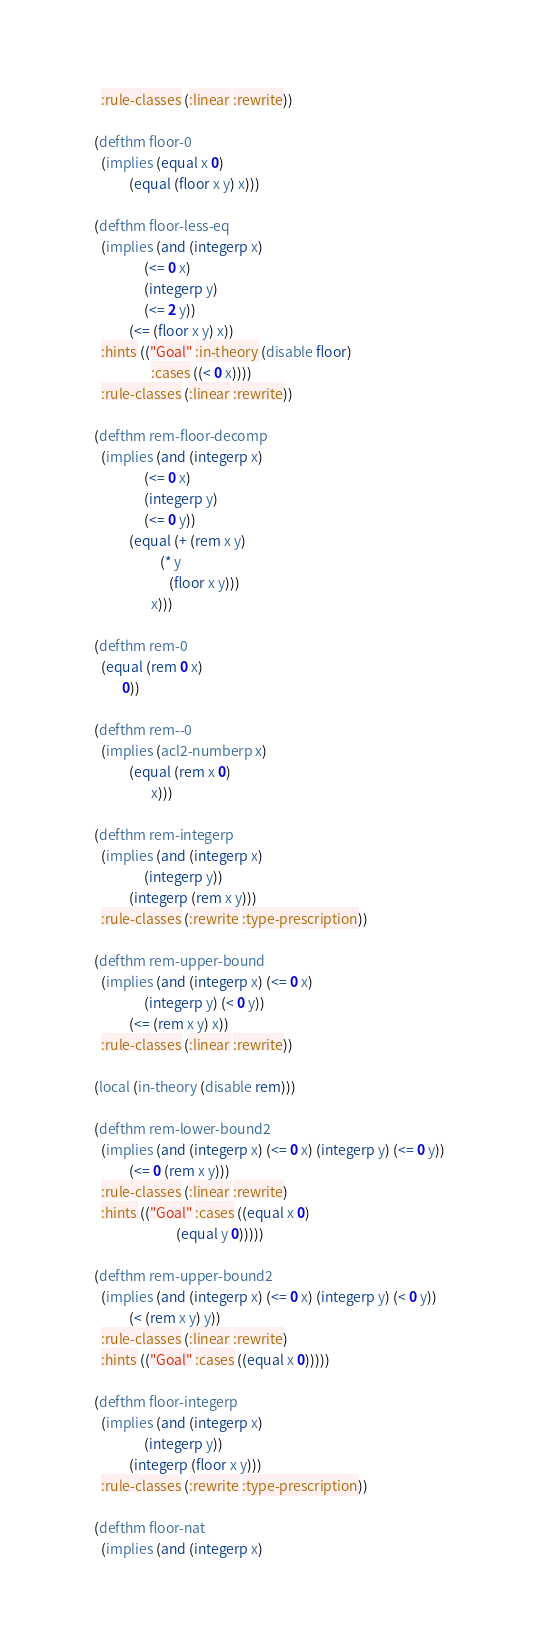<code> <loc_0><loc_0><loc_500><loc_500><_Lisp_>    :rule-classes (:linear :rewrite))
  
  (defthm floor-0
    (implies (equal x 0)
             (equal (floor x y) x)))
  
  (defthm floor-less-eq
    (implies (and (integerp x)
                  (<= 0 x)
                  (integerp y)
                  (<= 2 y))
             (<= (floor x y) x))
    :hints (("Goal" :in-theory (disable floor)
                    :cases ((< 0 x))))
    :rule-classes (:linear :rewrite))

  (defthm rem-floor-decomp
    (implies (and (integerp x)
                  (<= 0 x)
                  (integerp y)
                  (<= 0 y))
             (equal (+ (rem x y)
                       (* y
                          (floor x y)))
                    x)))
  
  (defthm rem-0
    (equal (rem 0 x)
           0))
  
  (defthm rem--0
    (implies (acl2-numberp x)
             (equal (rem x 0)
                    x)))
  
  (defthm rem-integerp
    (implies (and (integerp x)
                  (integerp y))
             (integerp (rem x y)))
    :rule-classes (:rewrite :type-prescription))
  
  (defthm rem-upper-bound
    (implies (and (integerp x) (<= 0 x)
                  (integerp y) (< 0 y))
             (<= (rem x y) x))
    :rule-classes (:linear :rewrite))

  (local (in-theory (disable rem)))
  
  (defthm rem-lower-bound2
    (implies (and (integerp x) (<= 0 x) (integerp y) (<= 0 y))
             (<= 0 (rem x y)))
    :rule-classes (:linear :rewrite)
    :hints (("Goal" :cases ((equal x 0)
                            (equal y 0)))))
  
  (defthm rem-upper-bound2
    (implies (and (integerp x) (<= 0 x) (integerp y) (< 0 y))
             (< (rem x y) y))
    :rule-classes (:linear :rewrite)
    :hints (("Goal" :cases ((equal x 0)))))
  
  (defthm floor-integerp
    (implies (and (integerp x)
                  (integerp y))
             (integerp (floor x y)))
    :rule-classes (:rewrite :type-prescription))
  
  (defthm floor-nat
    (implies (and (integerp x)</code> 